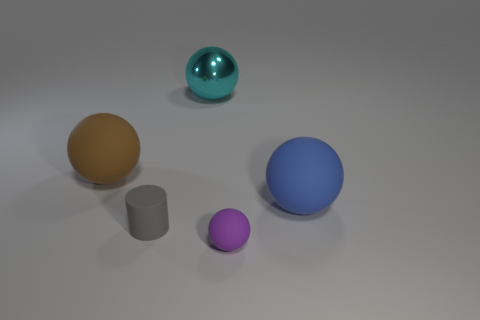Do the large rubber object that is on the right side of the purple ball and the small purple rubber thing have the same shape?
Offer a terse response. Yes. How many green things are either tiny matte cylinders or large things?
Your answer should be compact. 0. What material is the cyan thing that is the same shape as the small purple thing?
Make the answer very short. Metal. The matte object that is behind the blue rubber ball has what shape?
Ensure brevity in your answer.  Sphere. Is there a large cyan sphere that has the same material as the tiny purple sphere?
Provide a short and direct response. No. Do the brown matte thing and the blue sphere have the same size?
Your response must be concise. Yes. What number of blocks are cyan metallic objects or tiny purple things?
Provide a short and direct response. 0. How many brown things are the same shape as the gray thing?
Keep it short and to the point. 0. Is the number of spheres left of the large blue rubber ball greater than the number of purple matte balls on the right side of the small sphere?
Provide a succinct answer. Yes. Do the small matte ball that is in front of the gray matte cylinder and the rubber cylinder have the same color?
Ensure brevity in your answer.  No. 